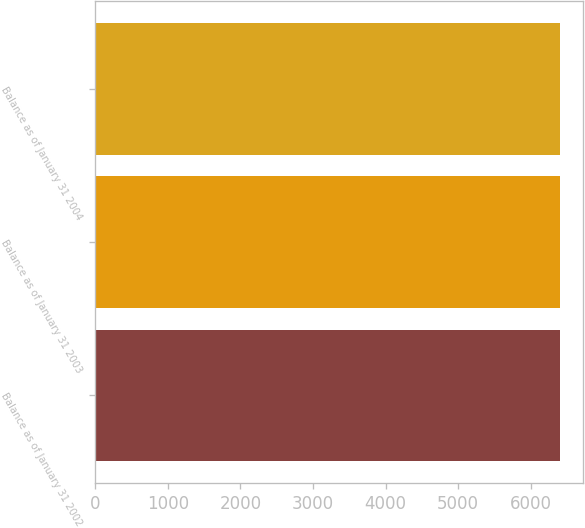Convert chart. <chart><loc_0><loc_0><loc_500><loc_500><bar_chart><fcel>Balance as of January 31 2002<fcel>Balance as of January 31 2003<fcel>Balance as of January 31 2004<nl><fcel>6406<fcel>6406.1<fcel>6406.2<nl></chart> 